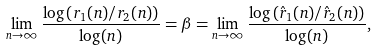<formula> <loc_0><loc_0><loc_500><loc_500>\lim _ { n \to \infty } \frac { \log \left ( r _ { 1 } ( n ) / r _ { 2 } ( n ) \right ) } { \log ( n ) } = \beta = \lim _ { n \to \infty } \frac { \log \left ( \hat { r } _ { 1 } ( n ) / \hat { r } _ { 2 } ( n ) \right ) } { \log ( n ) } ,</formula> 